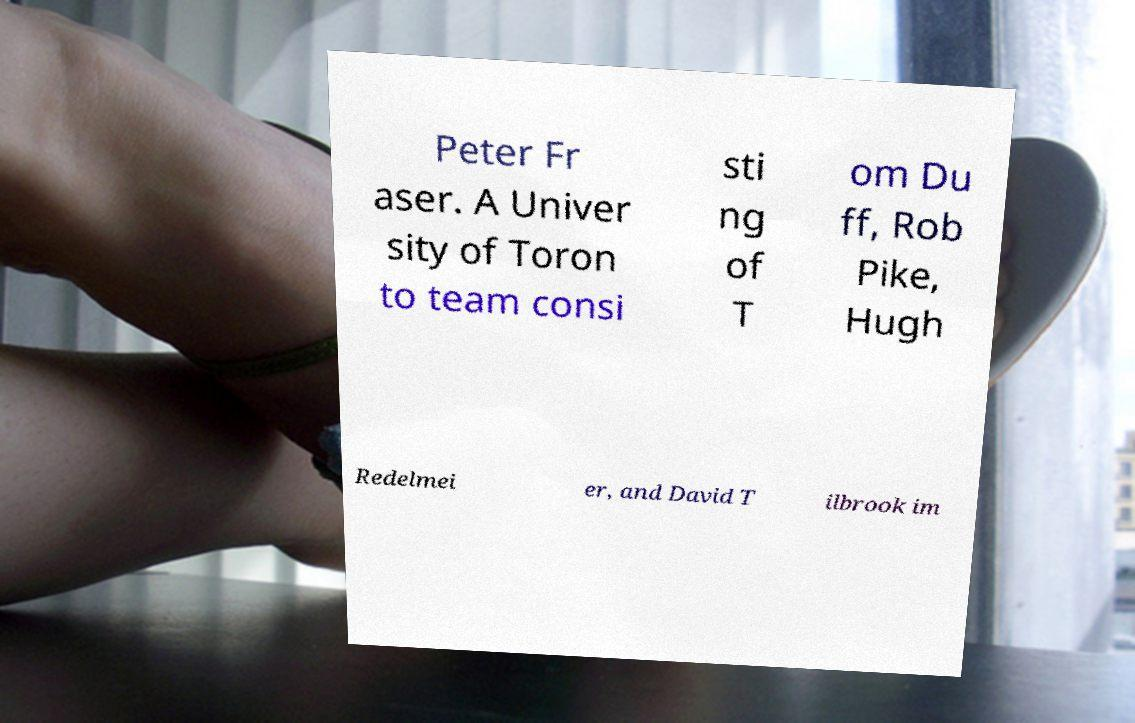Please read and relay the text visible in this image. What does it say? Peter Fr aser. A Univer sity of Toron to team consi sti ng of T om Du ff, Rob Pike, Hugh Redelmei er, and David T ilbrook im 